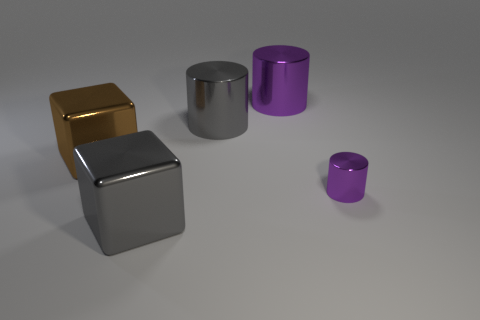Add 3 purple shiny cylinders. How many objects exist? 8 Subtract all blocks. How many objects are left? 3 Subtract all brown metal blocks. Subtract all gray shiny cylinders. How many objects are left? 3 Add 2 gray metal things. How many gray metal things are left? 4 Add 5 big gray metal cylinders. How many big gray metal cylinders exist? 6 Subtract 0 green spheres. How many objects are left? 5 